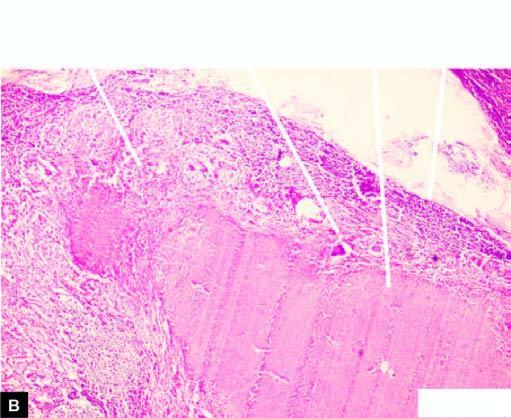does the nuclei show merging capsules and large areas of caseation necrosis?
Answer the question using a single word or phrase. No 